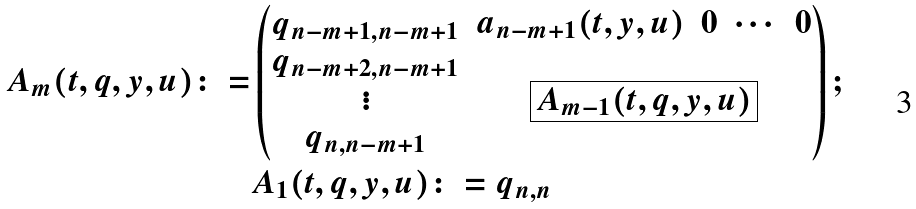<formula> <loc_0><loc_0><loc_500><loc_500>A _ { m } ( t , q , y , u ) \colon = & \left ( \begin{matrix} q _ { n - m + 1 , n - m + 1 } & \begin{matrix} a _ { n - m + 1 } ( t , y , u ) & 0 & \cdots & 0 \end{matrix} \\ \begin{matrix} q _ { n - m + 2 , n - m + 1 } \\ \vdots \\ q _ { n , n - m + 1 } \end{matrix} & \boxed { A _ { m - 1 } ( t , q , y , u ) } \end{matrix} \right ) ; \\ & A _ { 1 } ( t , q , y , u ) \colon = q _ { n , n }</formula> 